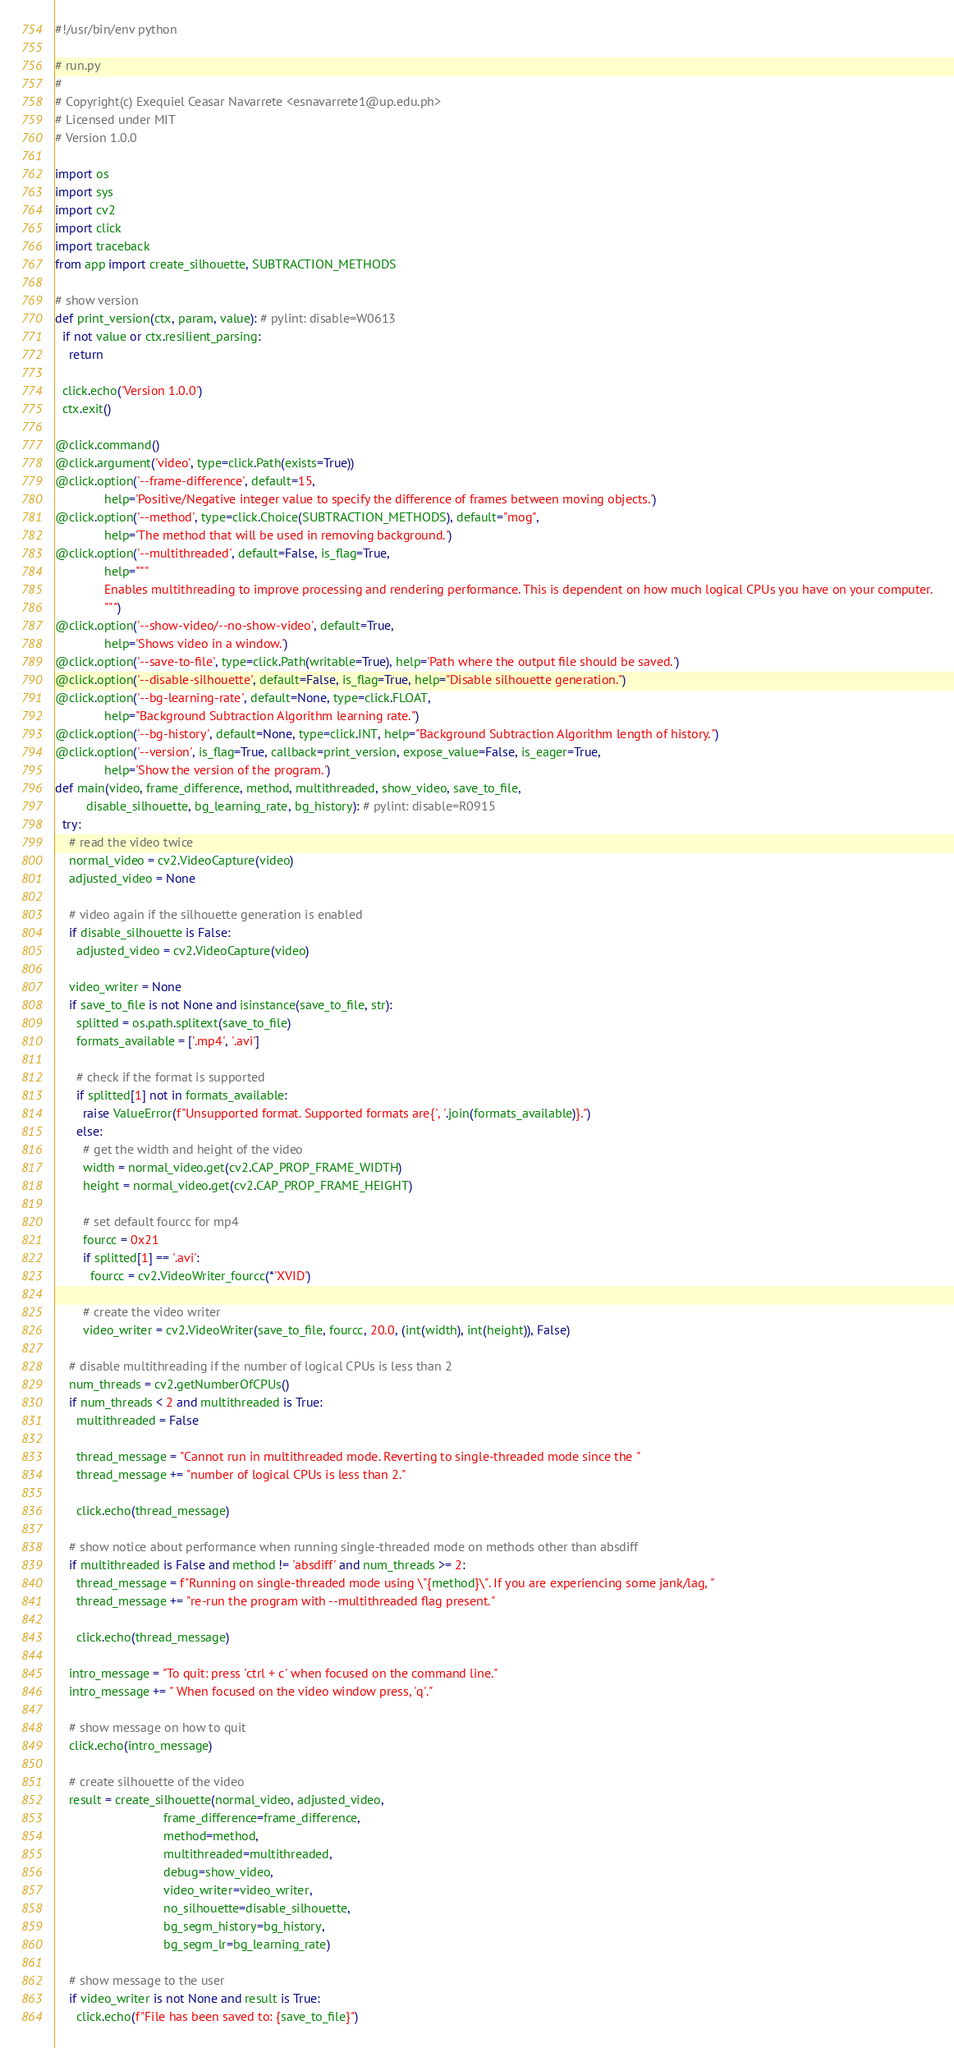<code> <loc_0><loc_0><loc_500><loc_500><_Python_>#!/usr/bin/env python

# run.py
#
# Copyright(c) Exequiel Ceasar Navarrete <esnavarrete1@up.edu.ph>
# Licensed under MIT
# Version 1.0.0

import os
import sys
import cv2
import click
import traceback
from app import create_silhouette, SUBTRACTION_METHODS

# show version
def print_version(ctx, param, value): # pylint: disable=W0613
  if not value or ctx.resilient_parsing:
    return

  click.echo('Version 1.0.0')
  ctx.exit()

@click.command()
@click.argument('video', type=click.Path(exists=True))
@click.option('--frame-difference', default=15,
              help='Positive/Negative integer value to specify the difference of frames between moving objects.')
@click.option('--method', type=click.Choice(SUBTRACTION_METHODS), default="mog",
              help='The method that will be used in removing background.')
@click.option('--multithreaded', default=False, is_flag=True,
              help="""
              Enables multithreading to improve processing and rendering performance. This is dependent on how much logical CPUs you have on your computer.
              """)
@click.option('--show-video/--no-show-video', default=True,
              help='Shows video in a window.')
@click.option('--save-to-file', type=click.Path(writable=True), help='Path where the output file should be saved.')
@click.option('--disable-silhouette', default=False, is_flag=True, help="Disable silhouette generation.")
@click.option('--bg-learning-rate', default=None, type=click.FLOAT,
              help="Background Subtraction Algorithm learning rate.")
@click.option('--bg-history', default=None, type=click.INT, help="Background Subtraction Algorithm length of history.")
@click.option('--version', is_flag=True, callback=print_version, expose_value=False, is_eager=True,
              help='Show the version of the program.')
def main(video, frame_difference, method, multithreaded, show_video, save_to_file,
         disable_silhouette, bg_learning_rate, bg_history): # pylint: disable=R0915
  try:
    # read the video twice
    normal_video = cv2.VideoCapture(video)
    adjusted_video = None

    # video again if the silhouette generation is enabled
    if disable_silhouette is False:
      adjusted_video = cv2.VideoCapture(video)

    video_writer = None
    if save_to_file is not None and isinstance(save_to_file, str):
      splitted = os.path.splitext(save_to_file)
      formats_available = ['.mp4', '.avi']

      # check if the format is supported
      if splitted[1] not in formats_available:
        raise ValueError(f"Unsupported format. Supported formats are{', '.join(formats_available)}.")
      else:
        # get the width and height of the video
        width = normal_video.get(cv2.CAP_PROP_FRAME_WIDTH)
        height = normal_video.get(cv2.CAP_PROP_FRAME_HEIGHT)

        # set default fourcc for mp4
        fourcc = 0x21
        if splitted[1] == '.avi':
          fourcc = cv2.VideoWriter_fourcc(*'XVID')

        # create the video writer
        video_writer = cv2.VideoWriter(save_to_file, fourcc, 20.0, (int(width), int(height)), False)

    # disable multithreading if the number of logical CPUs is less than 2
    num_threads = cv2.getNumberOfCPUs()
    if num_threads < 2 and multithreaded is True:
      multithreaded = False

      thread_message = "Cannot run in multithreaded mode. Reverting to single-threaded mode since the "
      thread_message += "number of logical CPUs is less than 2."

      click.echo(thread_message)

    # show notice about performance when running single-threaded mode on methods other than absdiff
    if multithreaded is False and method != 'absdiff' and num_threads >= 2:
      thread_message = f"Running on single-threaded mode using \"{method}\". If you are experiencing some jank/lag, "
      thread_message += "re-run the program with --multithreaded flag present."

      click.echo(thread_message)

    intro_message = "To quit: press 'ctrl + c' when focused on the command line."
    intro_message += " When focused on the video window press, 'q'."

    # show message on how to quit
    click.echo(intro_message)

    # create silhouette of the video
    result = create_silhouette(normal_video, adjusted_video,
                               frame_difference=frame_difference,
                               method=method,
                               multithreaded=multithreaded,
                               debug=show_video,
                               video_writer=video_writer,
                               no_silhouette=disable_silhouette,
                               bg_segm_history=bg_history,
                               bg_segm_lr=bg_learning_rate)

    # show message to the user
    if video_writer is not None and result is True:
      click.echo(f"File has been saved to: {save_to_file}")
</code> 